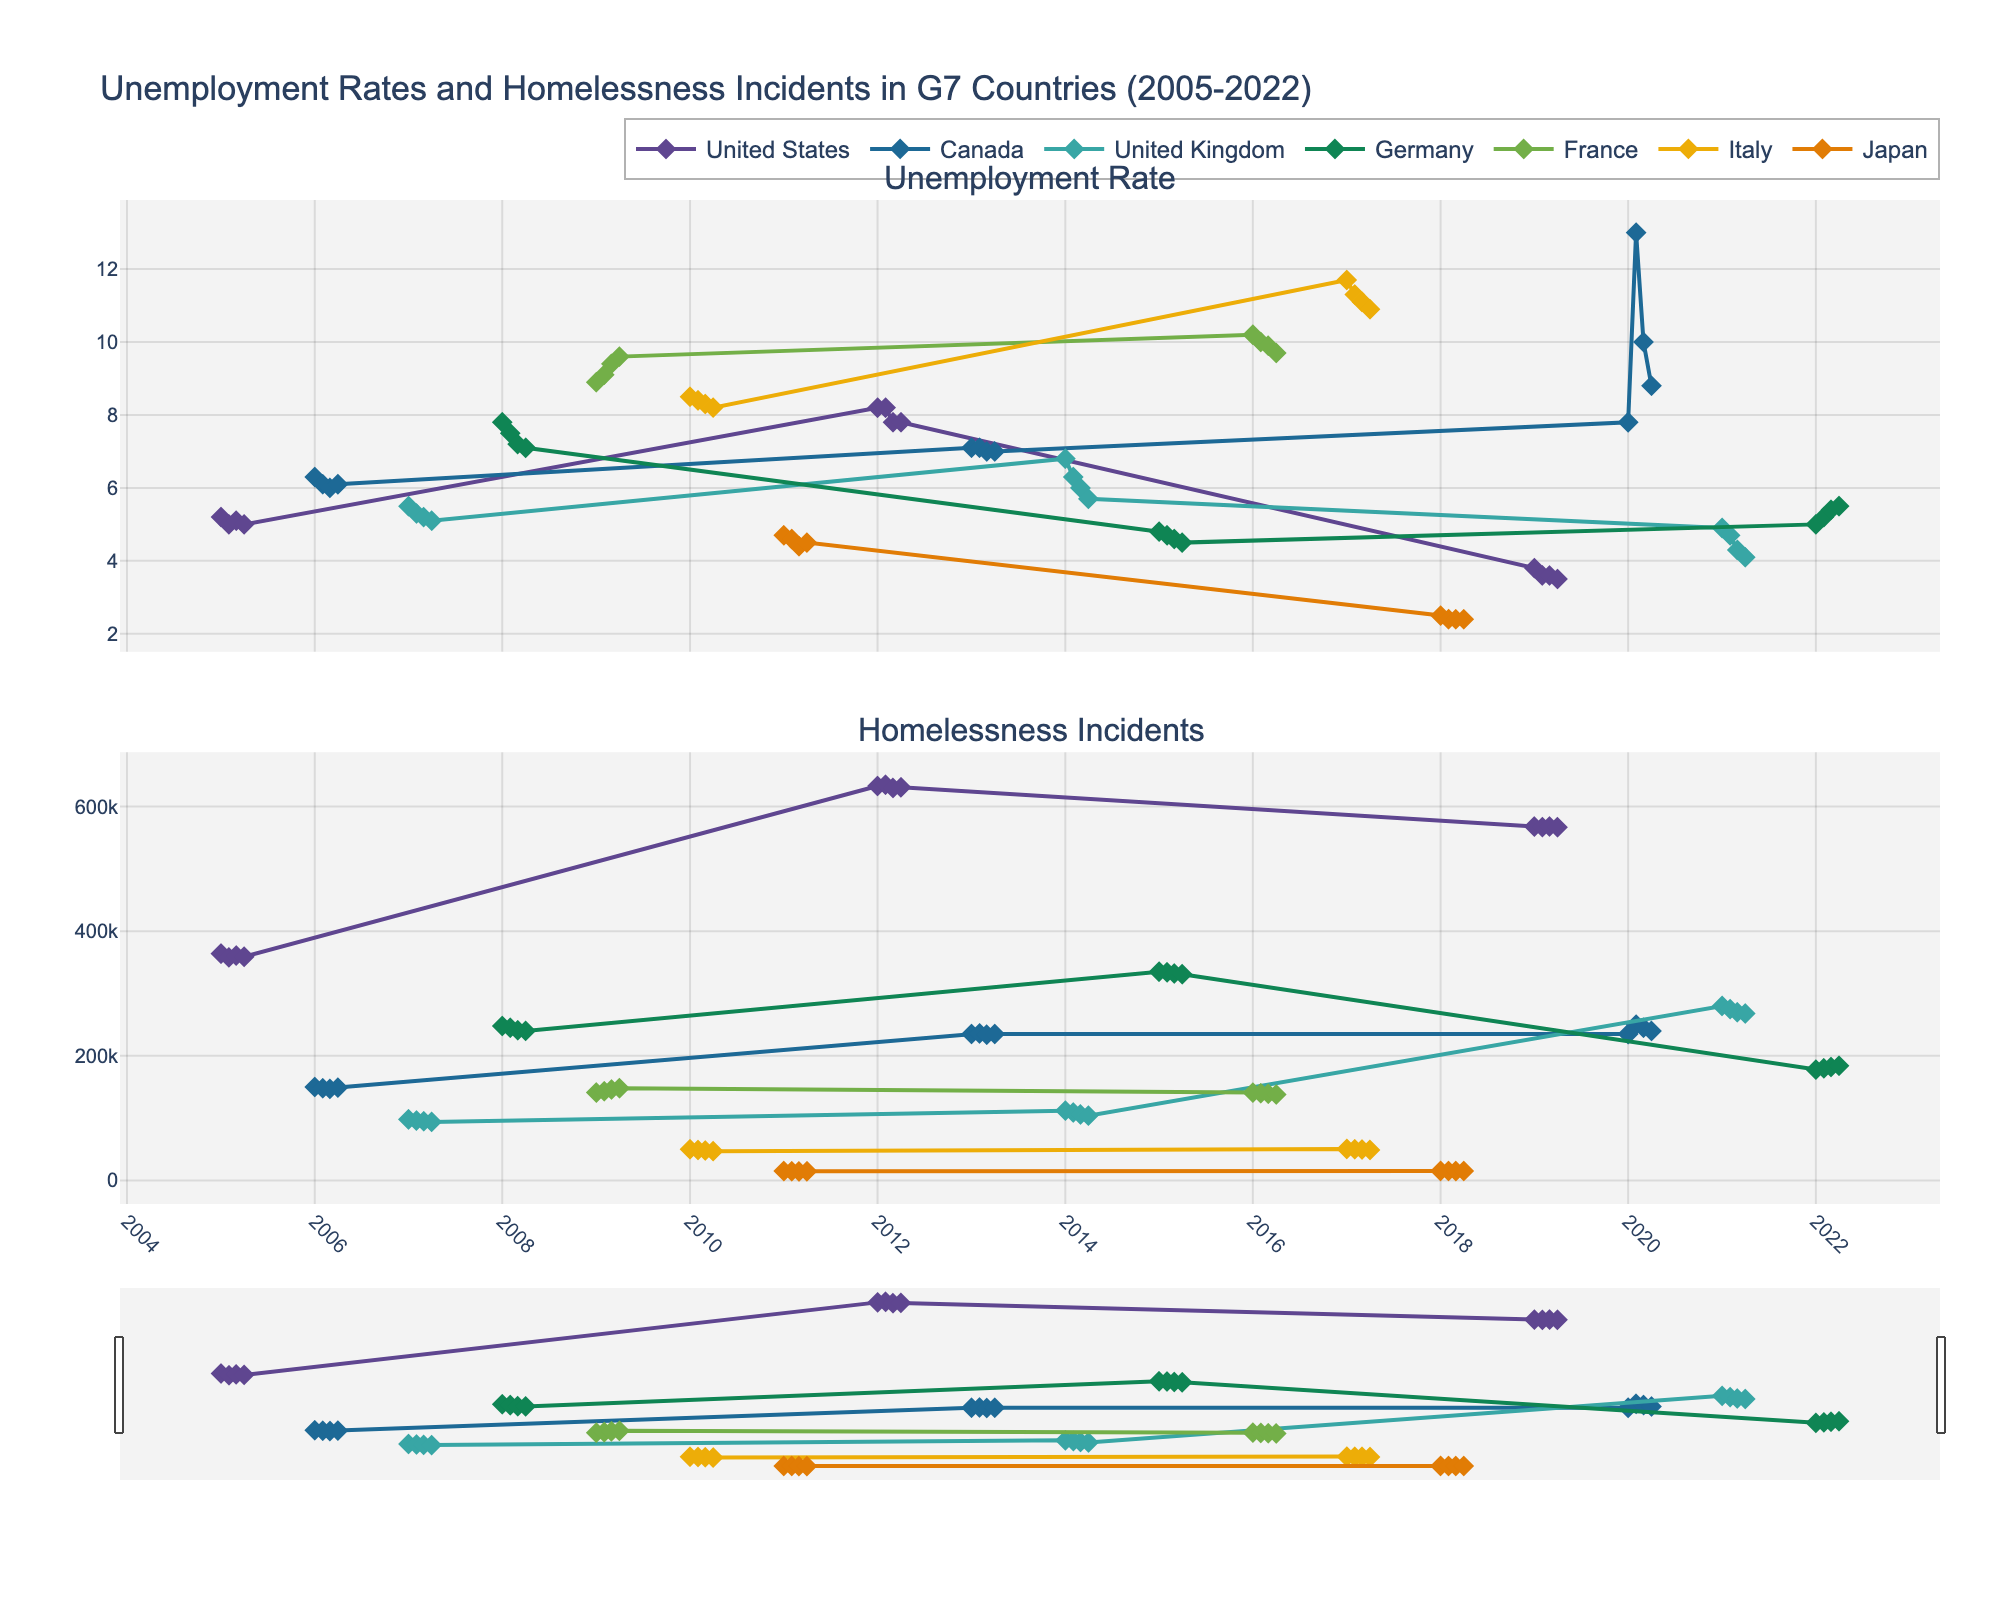What key patterns can be observed when comparing unemployment rates and homelessness incidents in G7 countries over time? This involves observing both subplots and identifying trends, such as whether an increase in unemployment rates coincides with an increase in homelessness incidents.
Answer: Generally, both metrics tend to show a positive correlation, where higher unemployment rates are often associated with more homelessness incidents, although the strength and specifics of this relationship can vary by country and over different periods How did the unemployment rate and homelessness incidents in Canada change from 2020 to 2022? Look at the lines representing Canada on both plots from 2020 to 2022 and observe the trajectories. The unemployment rate spiked in Q2 2020 and then declined, while homelessness incidents reflect a peak and subsequent drop but remained elevated.
Answer: The unemployment rate peaked in Q2 2020 and then decreased, while homelessness incidents peaked and slightly declined but stayed high Which country had the highest peak in unemployment rate and in which period did it occur? Check the subplot for unemployment rates and identify the highest point across all countries. The highest peak is for Canada in Q2 2020.
Answer: Canada in Q2 2020 What is the seasonal trend in homelessness incidents for Germany from 2017 to 2022? Look at the line representing Germany in the homelessness incidents subplot, and observe any recurring patterns within each year.
Answer: Seasonal variations are not very strong, but there is a general increasing trend from 178,000 incidents in Q1 2022 to 184,000 in Q4 2022 How does the trend in homelessness incidents in Japan compare to the trend in the United States? Compare the homelessness incidents lines for Japan and the United States. Japan has lower incidents with a relatively flat trend, while the United States shows higher counts and noticeable variability.
Answer: The United States has higher and more variable homelessness incidents, while Japan has lower and relatively stable numbers Between Q2 2020 and Q4 2020, which country saw a decrease in unemployment rate? Look at the unemployment rates in Q2 2020 and Q4 2020. Canada shows the most notable decrease from 13.0 to 8.8.
Answer: Canada Across all countries, are there any periods when homelessness incidents remain relatively stable despite changing unemployment rates? Analyze the plots to look for periods where variations in unemployment rate do not correspond to large changes in homelessness incidents. For the U.S., even with unemployment decreasing from Q1 2012 to Q4 2019, homelessness incidents remained significant around ~600,000.
Answer: United States from Q1 2012 to Q4 2019 What is the correlation between unemployment rates and homelessness incidents in the United Kingdom during the periods from 2007 to 2014? Observe the lines for the U.K. in both subplots and compare trends. Both metrics are decreasing over this period.
Answer: Both show a decreasing trend What were the unemployment rates for France in 2009 and how did these relate to homelessness incidents? Check unemployment rates for each quarter in 2009 in France and compare these to corresponding homelessness incidents. Both metrics increase slightly over the year.
Answer: Unemployment rates increased from 8.9 to 9.6, with homelessness incidents also showing a rising pattern from 141,000 to 148,000 